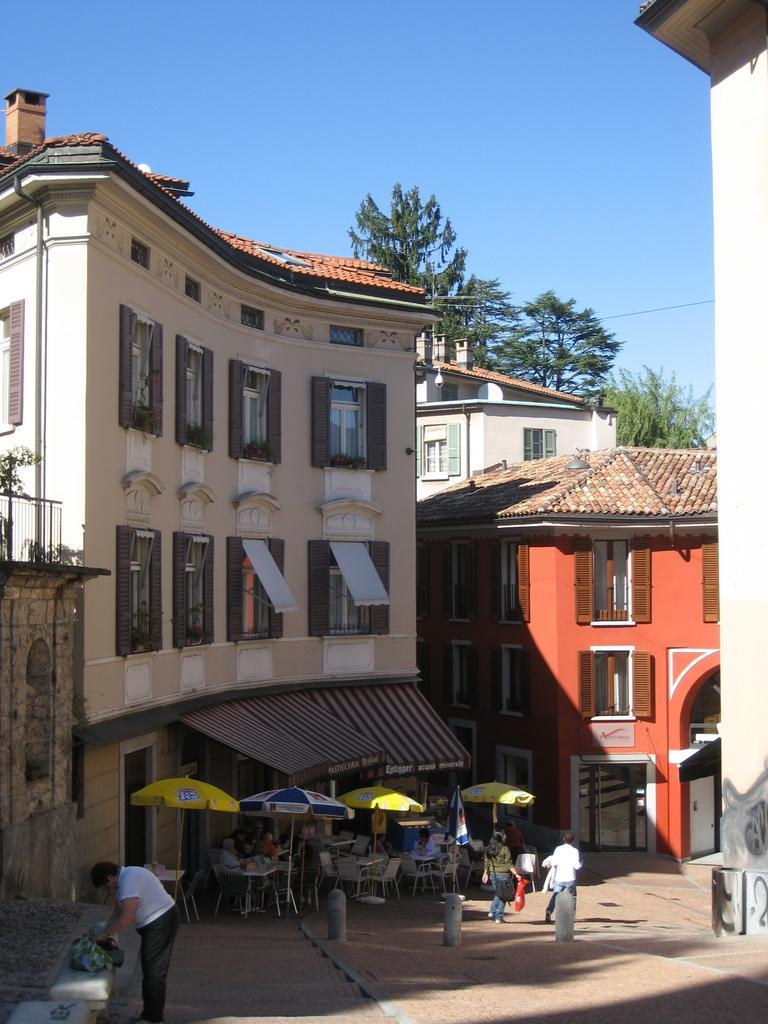How would you summarize this image in a sentence or two? Here we can see buildings,glass doors,windows,pipe on the wall,trees and sky. On the ground we can see few people standing,sitting on the chairs at the tables and there are umbrellas and a flag. 